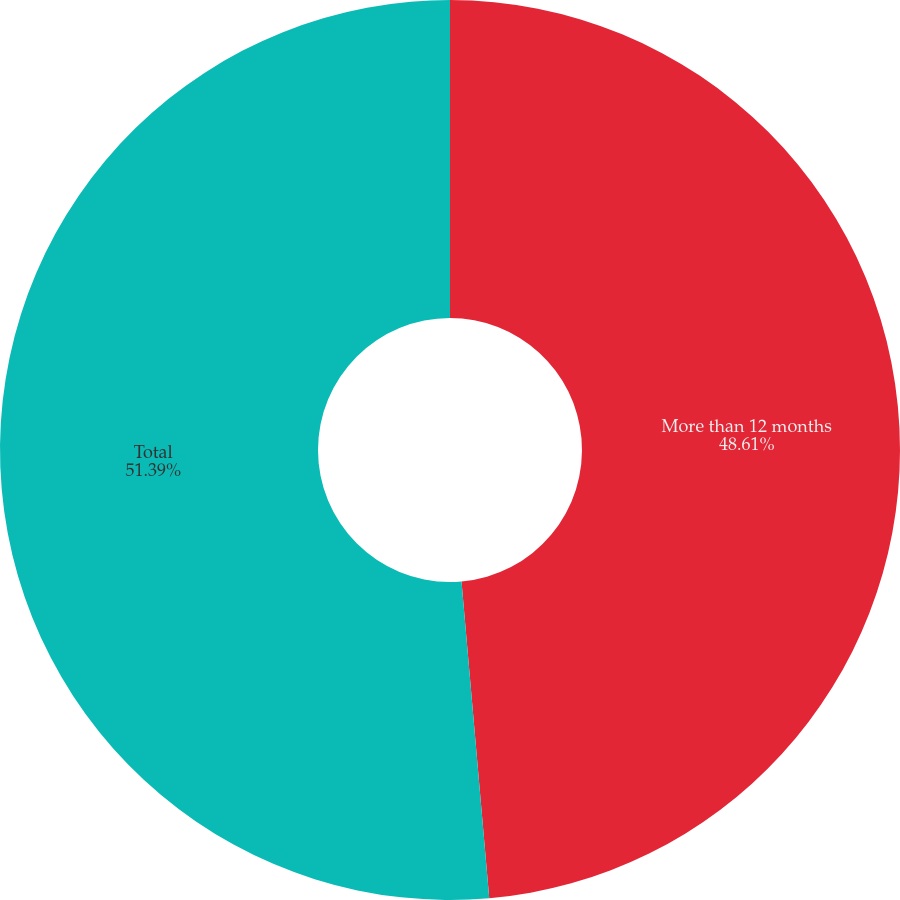Convert chart to OTSL. <chart><loc_0><loc_0><loc_500><loc_500><pie_chart><fcel>More than 12 months<fcel>Total<nl><fcel>48.61%<fcel>51.39%<nl></chart> 